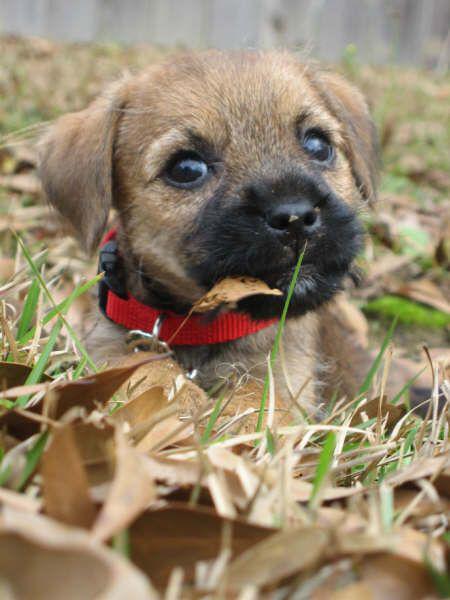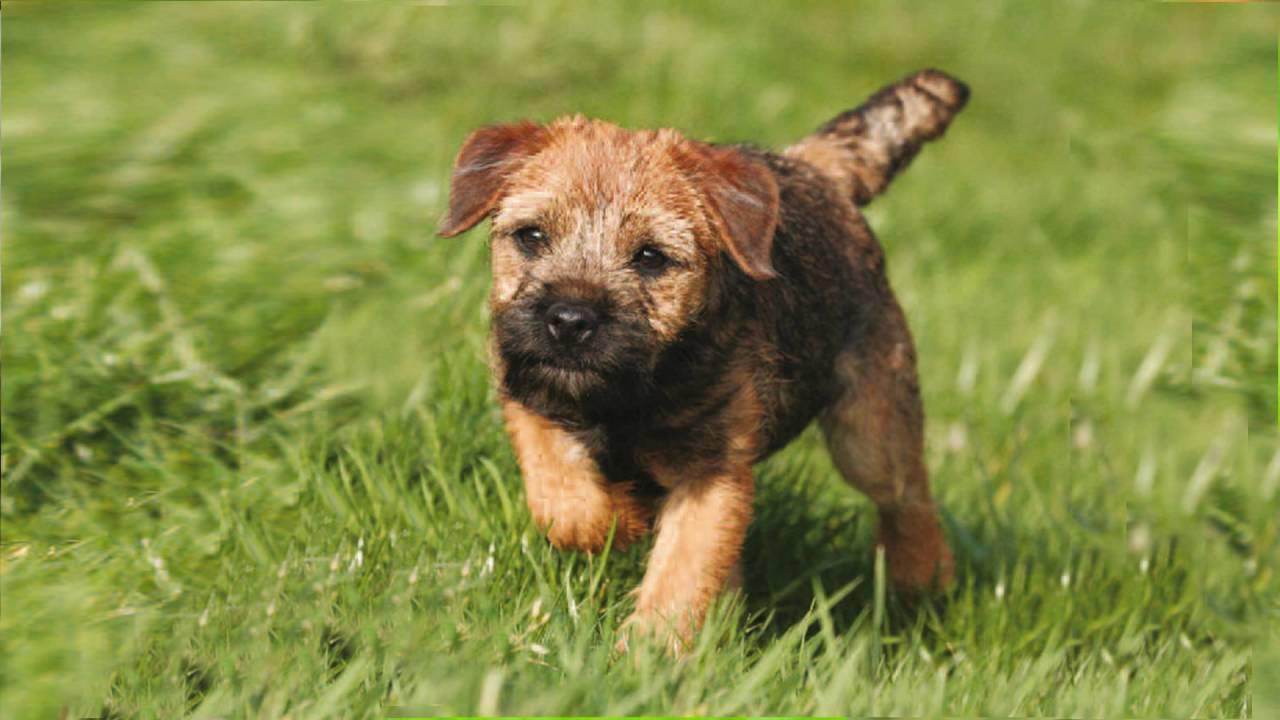The first image is the image on the left, the second image is the image on the right. For the images shown, is this caption "Two small dogs with floppy ears are in green grassy areas." true? Answer yes or no. No. The first image is the image on the left, the second image is the image on the right. For the images displayed, is the sentence "Right image shows puppy standing on grass with one paw raised." factually correct? Answer yes or no. Yes. 